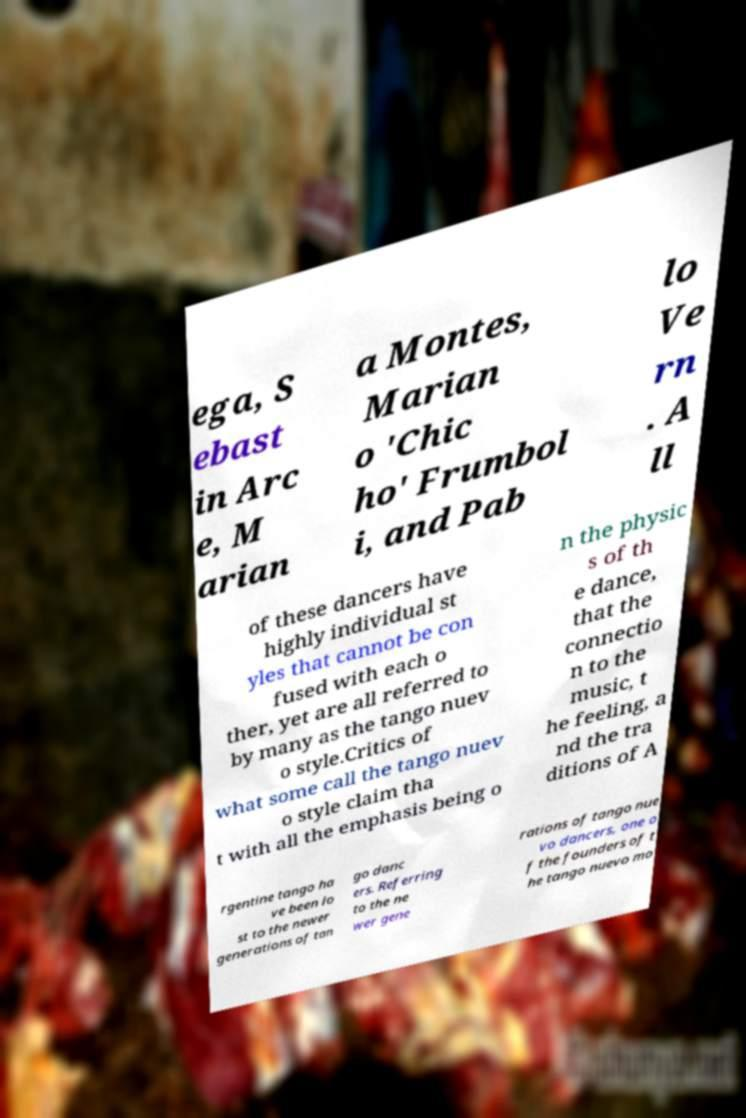I need the written content from this picture converted into text. Can you do that? ega, S ebast in Arc e, M arian a Montes, Marian o 'Chic ho' Frumbol i, and Pab lo Ve rn . A ll of these dancers have highly individual st yles that cannot be con fused with each o ther, yet are all referred to by many as the tango nuev o style.Critics of what some call the tango nuev o style claim tha t with all the emphasis being o n the physic s of th e dance, that the connectio n to the music, t he feeling, a nd the tra ditions of A rgentine tango ha ve been lo st to the newer generations of tan go danc ers. Referring to the ne wer gene rations of tango nue vo dancers, one o f the founders of t he tango nuevo mo 